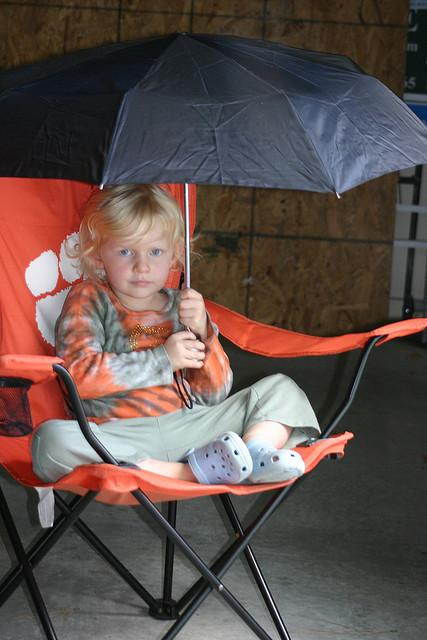What minimalizing action can this chair be made to do? fold 